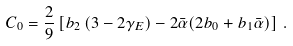Convert formula to latex. <formula><loc_0><loc_0><loc_500><loc_500>C _ { 0 } = \frac { 2 } { 9 } \left [ b _ { 2 } \left ( 3 - 2 \gamma _ { E } \right ) - 2 \bar { \alpha } ( 2 b _ { 0 } + b _ { 1 } \bar { \alpha } ) \right ] \, .</formula> 